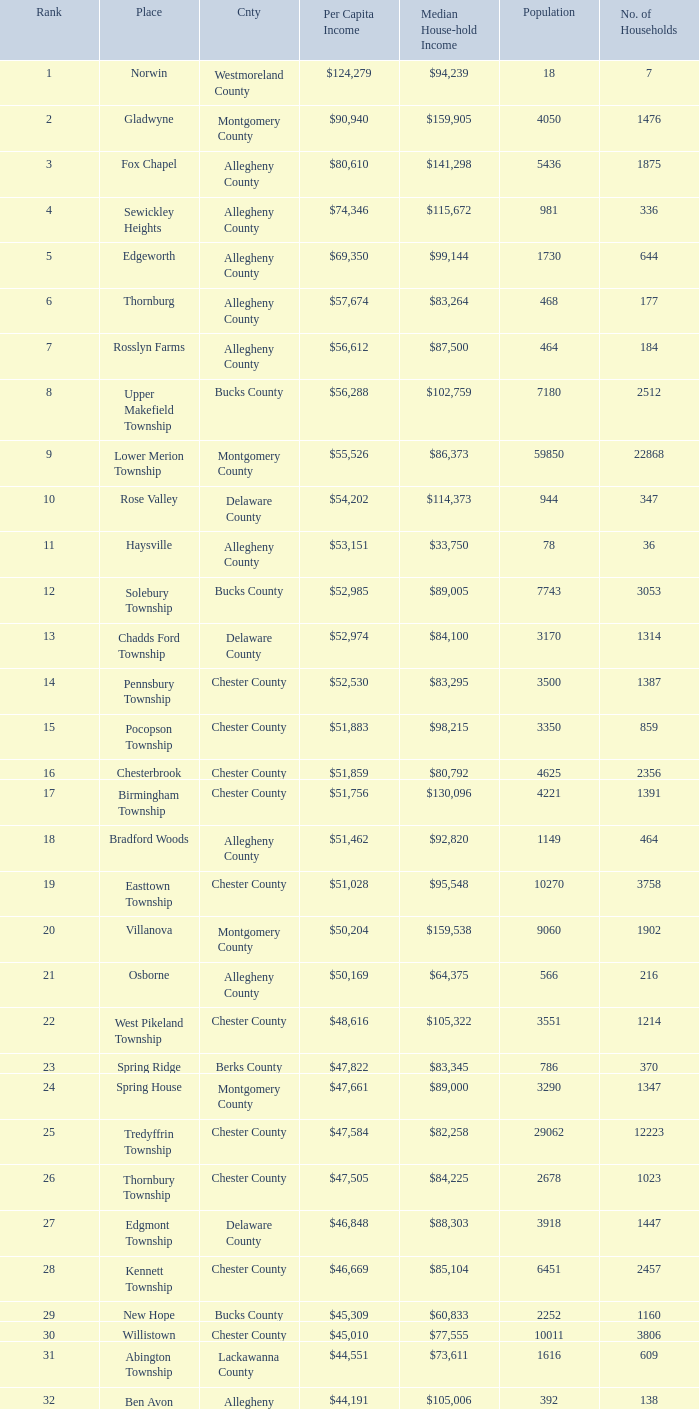What is the per capita income for Fayette County? $42,131. 